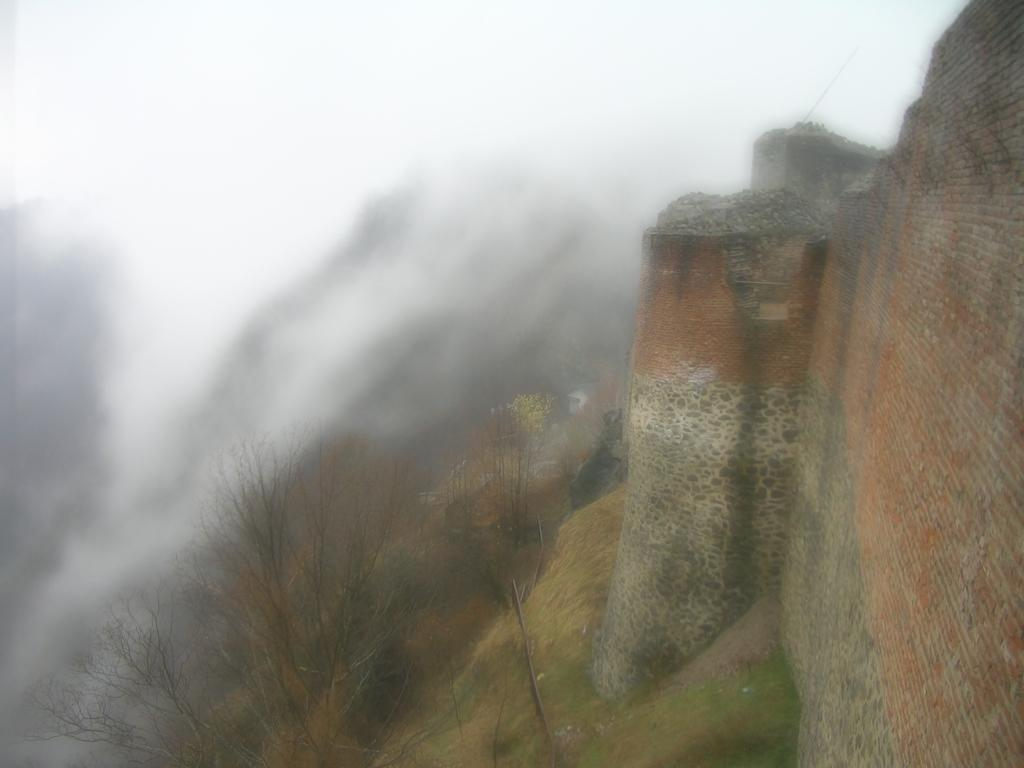What type of structure is located on the right side of the image? There is a brick wall on the right side of the image. What type of vegetation can be seen at the bottom of the image? Dry trees are present at the bottom of the image. What is the color of the sky in the image? The sky is white in color. Can you see a mine in the image? There is no mine present in the image. How many houses are visible in the image? There are no houses visible in the image. 